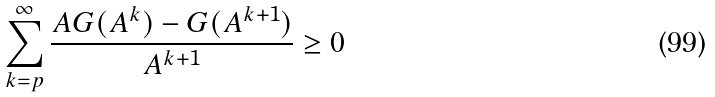<formula> <loc_0><loc_0><loc_500><loc_500>\sum _ { k = p } ^ { \infty } \frac { A G ( A ^ { k } ) - G ( A ^ { k + 1 } ) } { A ^ { k + 1 } } \geq 0</formula> 